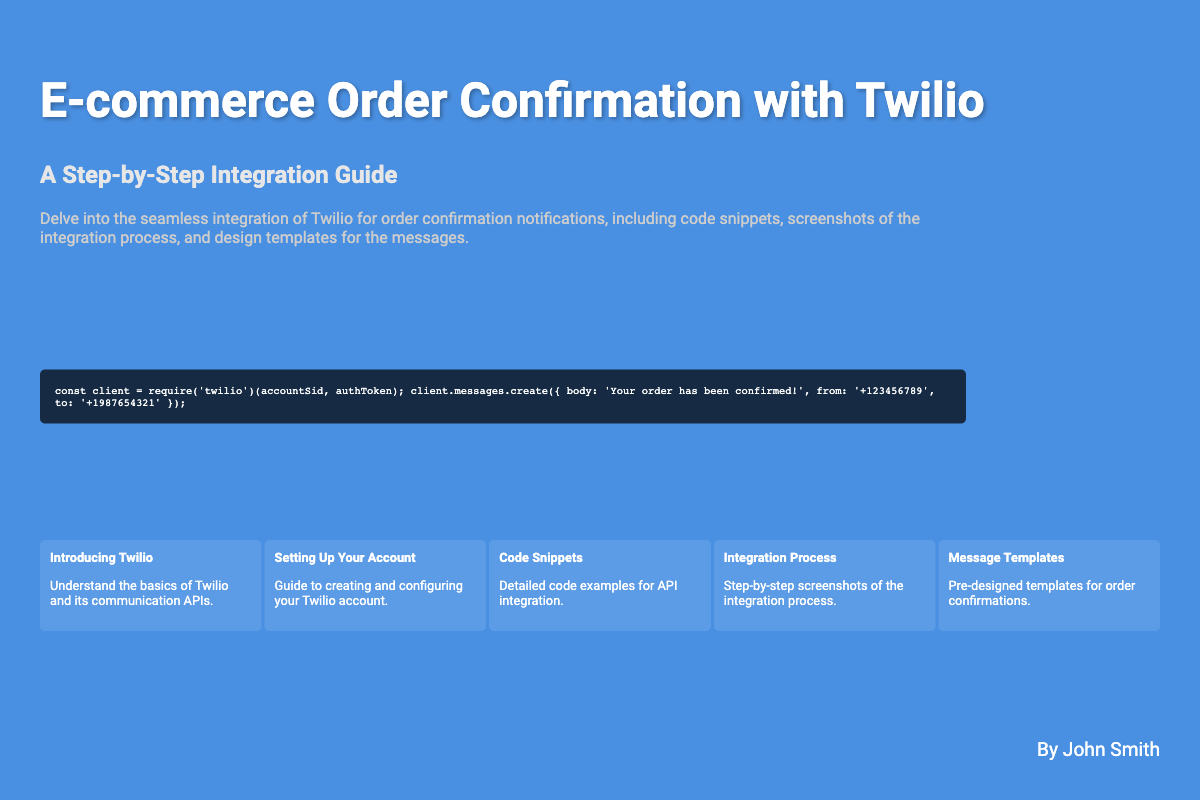What is the title of the book? The title is displayed prominently at the top of the document.
Answer: E-commerce Order Confirmation with Twilio Who is the author of the book? The author is mentioned at the bottom of the cover.
Answer: John Smith What is the main focus of the book? The description outlines the primary topic of the book.
Answer: Twilio for order confirmation notifications How many sections are presented in the book cover? The sections listed in the document provide insight into the content organization.
Answer: Five What is the second section about? The section titles are clearly labeled, indicating the content covered.
Answer: Setting Up Your Account What programming language is used in the code snippet? The coding style suggests the programming language being utilized.
Answer: JavaScript What is the opacity level of the image overlay? The image overlay description indicates the transparency of the image.
Answer: 0.2 What type of guide is this book classified as? The subtitle indicates the nature of the book.
Answer: Step-by-Step Integration Guide What color scheme is used for the book cover? The background color and text colors can be observed in the design.
Answer: Blue and white 